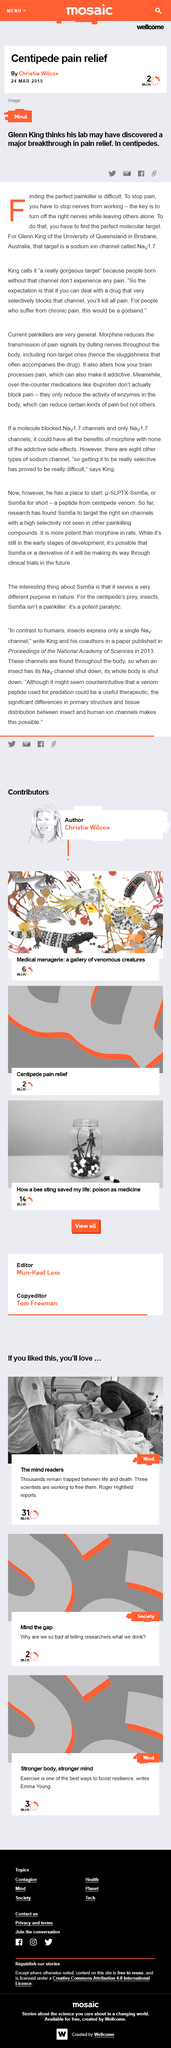Point out several critical features in this image. The identification of the sodium ion channel Nav 1.7 is significant because it provides a target for the development of drugs that can selectively block this channel in order to alleviate chronic pain in individuals. The research being conducted by Glenn King involves the use of centipedes to investigate pain relief. People who are born without the Nav1.7 sodium ion channel cannot experience pain. This is because the absence of this channel prevents the proper transmission of nerve impulses that are responsible for sensing pain. Individuals who are born without Nav1.7 are often insensitive to pain, making everyday activities that may cause discomfort or injury for others, such as touching a hot stove or stepping on a sharp object, completely painless for them. 